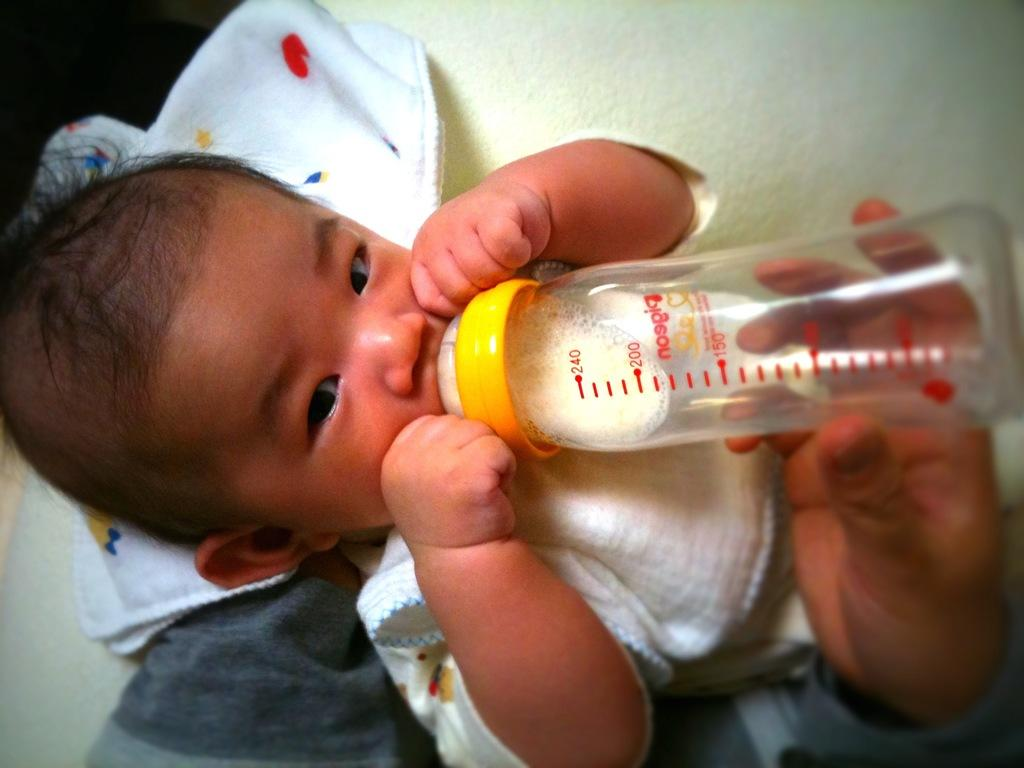Who is the main subject in the image? The main subject in the image is a little boy. What is the little boy holding in the image? The boy is holding a bottle in the image. Is there anyone else in the image providing assistance to the little boy? Yes, another person is providing support to the boy by holding his hand. What type of root can be seen growing on the page in the image? There is no root or page present in the image; it features a little boy holding a bottle and receiving support from another person. 